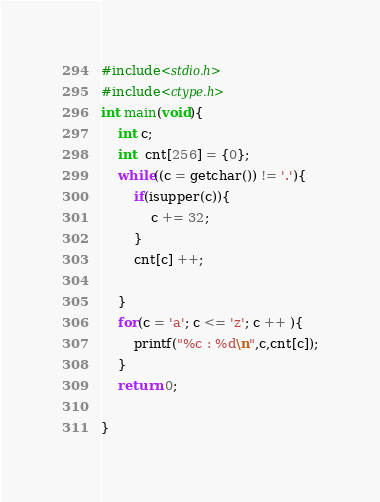<code> <loc_0><loc_0><loc_500><loc_500><_C_>#include<stdio.h>
#include<ctype.h>
int main(void){
    int c;
    int  cnt[256] = {0};
    while((c = getchar()) != '.'){
        if(isupper(c)){
            c += 32;
        }
        cnt[c] ++;
        
    }
    for(c = 'a'; c <= 'z'; c ++ ){
        printf("%c : %d\n",c,cnt[c]);
    }
    return 0;
    
}</code> 